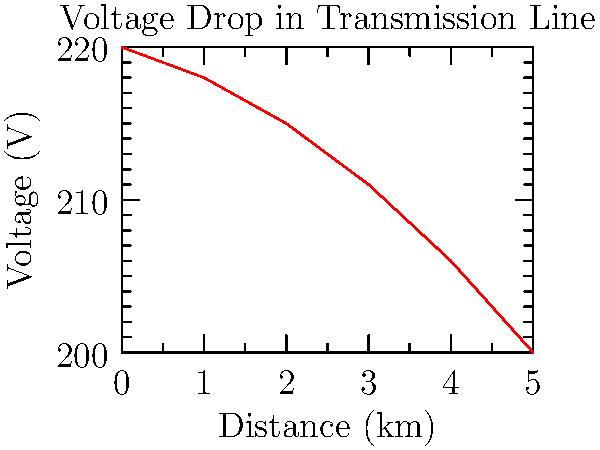Based on the line graph showing voltage drop across a transmission line in a coal mining facility, what is the approximate voltage drop per kilometer of the line? To calculate the voltage drop per kilometer:

1. Identify the start and end points:
   Start: 0 km, 220 V
   End: 5 km, 200 V

2. Calculate total voltage drop:
   $\Delta V = 220 \text{ V} - 200 \text{ V} = 20 \text{ V}$

3. Calculate total distance:
   $\Delta d = 5 \text{ km} - 0 \text{ km} = 5 \text{ km}$

4. Calculate voltage drop per kilometer:
   $\frac{\Delta V}{\Delta d} = \frac{20 \text{ V}}{5 \text{ km}} = 4 \text{ V/km}$

Therefore, the approximate voltage drop per kilometer is 4 V/km.
Answer: 4 V/km 